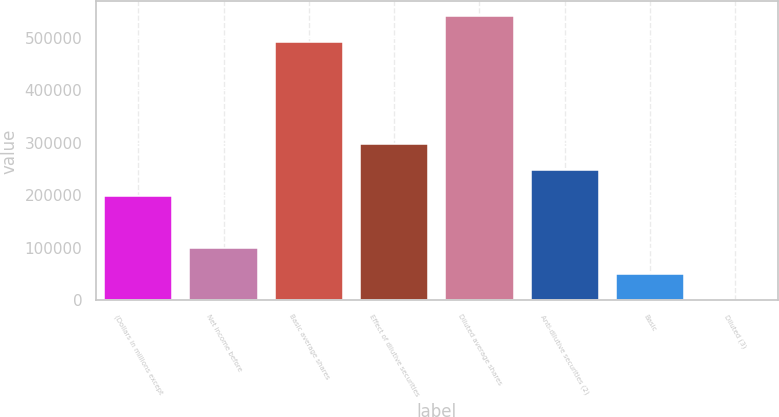Convert chart to OTSL. <chart><loc_0><loc_0><loc_500><loc_500><bar_chart><fcel>(Dollars in millions except<fcel>Net income before<fcel>Basic average shares<fcel>Effect of dilutive securities<fcel>Diluted average shares<fcel>Anti-dilutive securities (2)<fcel>Basic<fcel>Diluted (3)<nl><fcel>198431<fcel>99217.4<fcel>492598<fcel>297645<fcel>542205<fcel>248038<fcel>49610.6<fcel>3.79<nl></chart> 